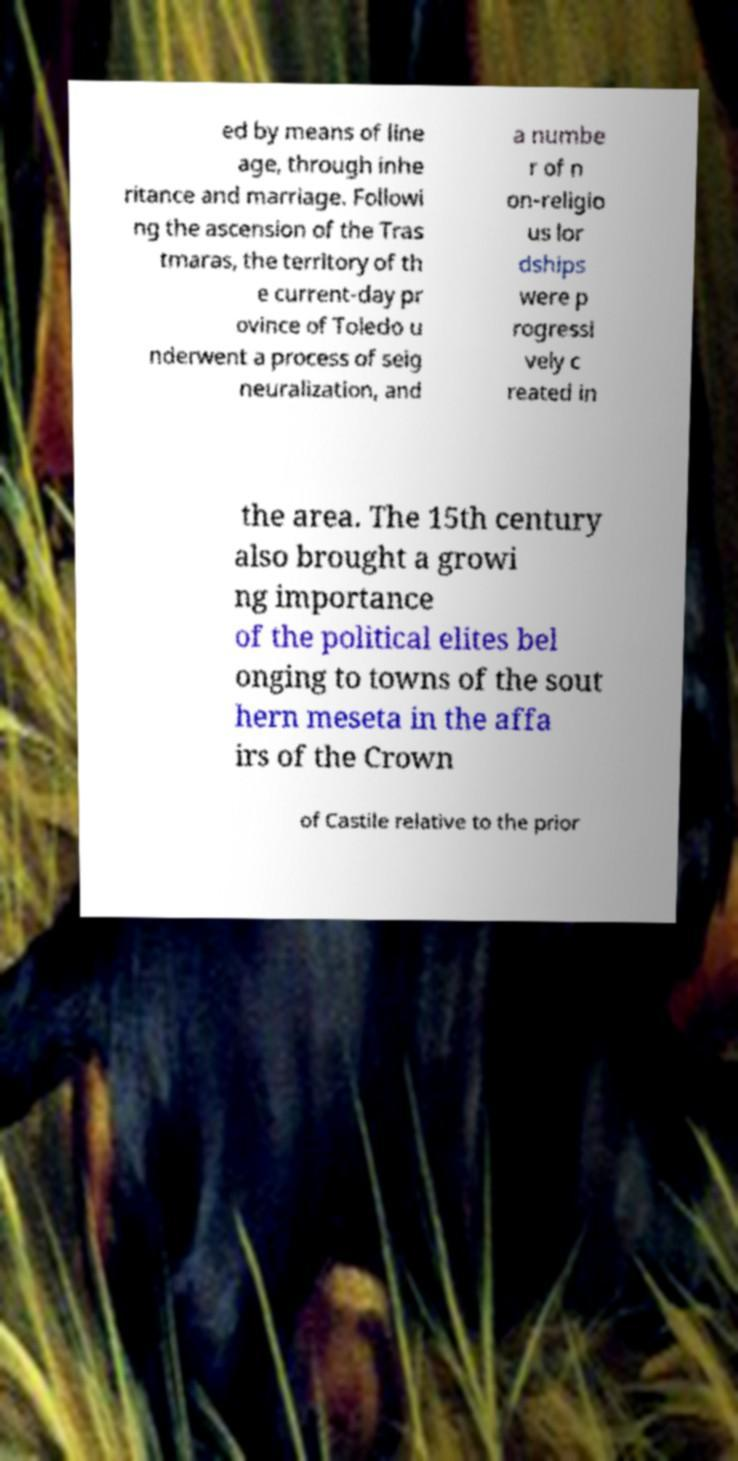Could you assist in decoding the text presented in this image and type it out clearly? ed by means of line age, through inhe ritance and marriage. Followi ng the ascension of the Tras tmaras, the territory of th e current-day pr ovince of Toledo u nderwent a process of seig neuralization, and a numbe r of n on-religio us lor dships were p rogressi vely c reated in the area. The 15th century also brought a growi ng importance of the political elites bel onging to towns of the sout hern meseta in the affa irs of the Crown of Castile relative to the prior 